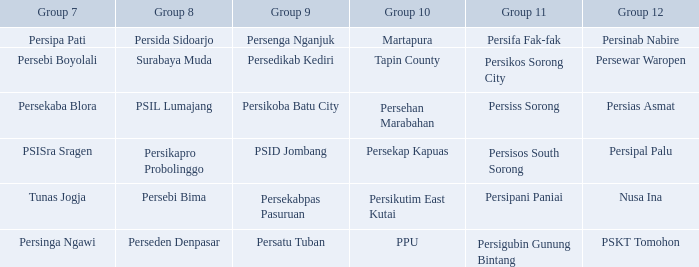Who played in group 8 when Persinab Nabire played in Group 12? Persida Sidoarjo. 